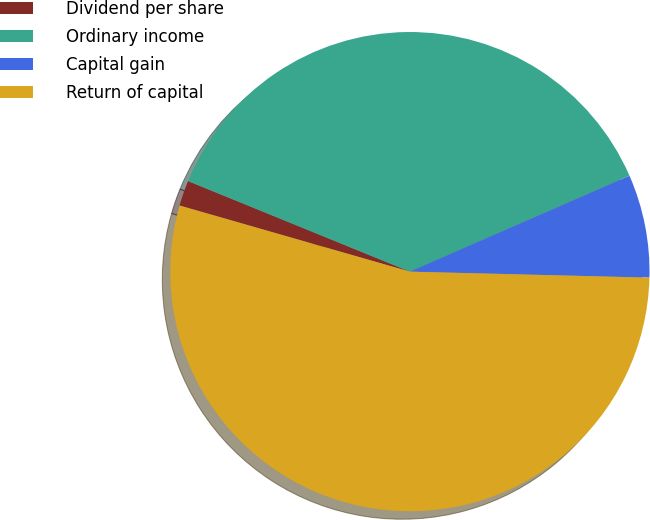Convert chart to OTSL. <chart><loc_0><loc_0><loc_500><loc_500><pie_chart><fcel>Dividend per share<fcel>Ordinary income<fcel>Capital gain<fcel>Return of capital<nl><fcel>1.72%<fcel>37.28%<fcel>6.95%<fcel>54.05%<nl></chart> 